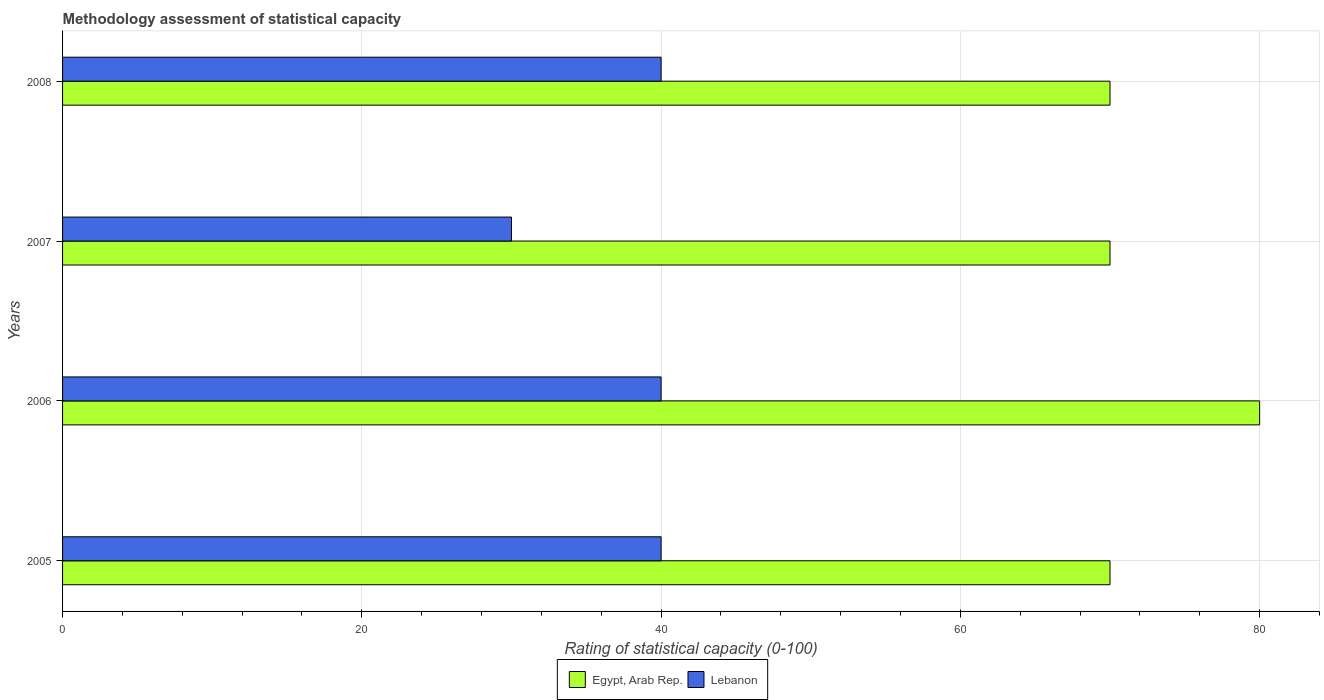How many different coloured bars are there?
Provide a short and direct response. 2. How many groups of bars are there?
Ensure brevity in your answer.  4. Are the number of bars on each tick of the Y-axis equal?
Make the answer very short. Yes. What is the label of the 2nd group of bars from the top?
Keep it short and to the point. 2007. What is the rating of statistical capacity in Egypt, Arab Rep. in 2008?
Keep it short and to the point. 70. Across all years, what is the maximum rating of statistical capacity in Egypt, Arab Rep.?
Your answer should be compact. 80. Across all years, what is the minimum rating of statistical capacity in Lebanon?
Keep it short and to the point. 30. In which year was the rating of statistical capacity in Egypt, Arab Rep. maximum?
Give a very brief answer. 2006. What is the total rating of statistical capacity in Lebanon in the graph?
Keep it short and to the point. 150. What is the difference between the rating of statistical capacity in Egypt, Arab Rep. in 2006 and that in 2007?
Ensure brevity in your answer.  10. What is the difference between the rating of statistical capacity in Egypt, Arab Rep. in 2006 and the rating of statistical capacity in Lebanon in 2007?
Provide a succinct answer. 50. What is the average rating of statistical capacity in Lebanon per year?
Keep it short and to the point. 37.5. In the year 2008, what is the difference between the rating of statistical capacity in Lebanon and rating of statistical capacity in Egypt, Arab Rep.?
Make the answer very short. -30. What is the ratio of the rating of statistical capacity in Egypt, Arab Rep. in 2006 to that in 2008?
Your answer should be compact. 1.14. Is the difference between the rating of statistical capacity in Lebanon in 2006 and 2007 greater than the difference between the rating of statistical capacity in Egypt, Arab Rep. in 2006 and 2007?
Offer a terse response. No. What is the difference between the highest and the second highest rating of statistical capacity in Lebanon?
Offer a terse response. 0. What is the difference between the highest and the lowest rating of statistical capacity in Egypt, Arab Rep.?
Your answer should be very brief. 10. In how many years, is the rating of statistical capacity in Lebanon greater than the average rating of statistical capacity in Lebanon taken over all years?
Give a very brief answer. 3. What does the 2nd bar from the top in 2008 represents?
Make the answer very short. Egypt, Arab Rep. What does the 2nd bar from the bottom in 2005 represents?
Your response must be concise. Lebanon. How many bars are there?
Give a very brief answer. 8. Are all the bars in the graph horizontal?
Make the answer very short. Yes. How many years are there in the graph?
Provide a short and direct response. 4. What is the difference between two consecutive major ticks on the X-axis?
Offer a very short reply. 20. Does the graph contain grids?
Your answer should be very brief. Yes. How many legend labels are there?
Your answer should be compact. 2. How are the legend labels stacked?
Provide a succinct answer. Horizontal. What is the title of the graph?
Make the answer very short. Methodology assessment of statistical capacity. What is the label or title of the X-axis?
Keep it short and to the point. Rating of statistical capacity (0-100). What is the label or title of the Y-axis?
Your answer should be very brief. Years. What is the Rating of statistical capacity (0-100) of Lebanon in 2005?
Your answer should be compact. 40. What is the Rating of statistical capacity (0-100) of Lebanon in 2006?
Make the answer very short. 40. What is the Rating of statistical capacity (0-100) in Egypt, Arab Rep. in 2007?
Give a very brief answer. 70. Across all years, what is the maximum Rating of statistical capacity (0-100) in Egypt, Arab Rep.?
Ensure brevity in your answer.  80. Across all years, what is the maximum Rating of statistical capacity (0-100) of Lebanon?
Your response must be concise. 40. Across all years, what is the minimum Rating of statistical capacity (0-100) in Egypt, Arab Rep.?
Give a very brief answer. 70. Across all years, what is the minimum Rating of statistical capacity (0-100) in Lebanon?
Keep it short and to the point. 30. What is the total Rating of statistical capacity (0-100) in Egypt, Arab Rep. in the graph?
Your answer should be compact. 290. What is the total Rating of statistical capacity (0-100) in Lebanon in the graph?
Keep it short and to the point. 150. What is the difference between the Rating of statistical capacity (0-100) in Lebanon in 2005 and that in 2006?
Your answer should be compact. 0. What is the difference between the Rating of statistical capacity (0-100) in Egypt, Arab Rep. in 2005 and that in 2007?
Offer a terse response. 0. What is the difference between the Rating of statistical capacity (0-100) in Lebanon in 2005 and that in 2008?
Provide a short and direct response. 0. What is the difference between the Rating of statistical capacity (0-100) of Egypt, Arab Rep. in 2006 and that in 2007?
Offer a terse response. 10. What is the difference between the Rating of statistical capacity (0-100) of Egypt, Arab Rep. in 2006 and that in 2008?
Provide a succinct answer. 10. What is the difference between the Rating of statistical capacity (0-100) in Lebanon in 2006 and that in 2008?
Provide a succinct answer. 0. What is the difference between the Rating of statistical capacity (0-100) of Egypt, Arab Rep. in 2007 and that in 2008?
Keep it short and to the point. 0. What is the difference between the Rating of statistical capacity (0-100) of Lebanon in 2007 and that in 2008?
Ensure brevity in your answer.  -10. What is the difference between the Rating of statistical capacity (0-100) in Egypt, Arab Rep. in 2005 and the Rating of statistical capacity (0-100) in Lebanon in 2006?
Offer a very short reply. 30. What is the difference between the Rating of statistical capacity (0-100) in Egypt, Arab Rep. in 2005 and the Rating of statistical capacity (0-100) in Lebanon in 2008?
Offer a terse response. 30. What is the difference between the Rating of statistical capacity (0-100) in Egypt, Arab Rep. in 2007 and the Rating of statistical capacity (0-100) in Lebanon in 2008?
Provide a short and direct response. 30. What is the average Rating of statistical capacity (0-100) in Egypt, Arab Rep. per year?
Offer a terse response. 72.5. What is the average Rating of statistical capacity (0-100) in Lebanon per year?
Offer a very short reply. 37.5. What is the ratio of the Rating of statistical capacity (0-100) in Egypt, Arab Rep. in 2005 to that in 2006?
Provide a succinct answer. 0.88. What is the ratio of the Rating of statistical capacity (0-100) in Lebanon in 2005 to that in 2006?
Your answer should be very brief. 1. What is the ratio of the Rating of statistical capacity (0-100) of Lebanon in 2005 to that in 2007?
Provide a succinct answer. 1.33. What is the ratio of the Rating of statistical capacity (0-100) of Egypt, Arab Rep. in 2006 to that in 2007?
Your answer should be very brief. 1.14. What is the ratio of the Rating of statistical capacity (0-100) in Egypt, Arab Rep. in 2006 to that in 2008?
Your answer should be very brief. 1.14. What is the ratio of the Rating of statistical capacity (0-100) in Lebanon in 2006 to that in 2008?
Offer a terse response. 1. What is the ratio of the Rating of statistical capacity (0-100) of Egypt, Arab Rep. in 2007 to that in 2008?
Give a very brief answer. 1. What is the ratio of the Rating of statistical capacity (0-100) in Lebanon in 2007 to that in 2008?
Make the answer very short. 0.75. What is the difference between the highest and the second highest Rating of statistical capacity (0-100) of Egypt, Arab Rep.?
Offer a terse response. 10. What is the difference between the highest and the second highest Rating of statistical capacity (0-100) of Lebanon?
Make the answer very short. 0. 